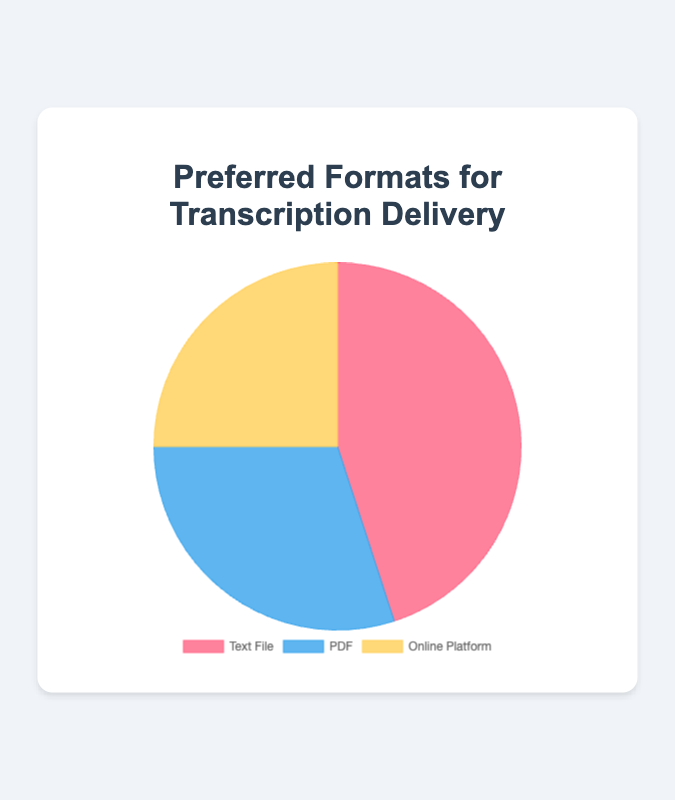How many more preferences are there for Text Files compared to Online Platforms? The number of preferences for Text Files is 45, while for Online Platforms it is 25. To find the difference, subtract the number of preferences for Online Platforms from Text Files: 45 - 25.
Answer: 20 What percentage of the total preferences is for PDF format? First, find the total number of preferences by summing up the values for Text File, PDF, and Online Platform: 45 + 30 + 25 = 100. The percentage for PDF is (30/100) * 100%.
Answer: 30% Which transcription delivery format has the least preference? By comparing the numbers, Text File has 45, PDF has 30, and Online Platform has 25 preferences. The smallest value is 25.
Answer: Online Platform What is the combined preference percentage for PDF and Online Platform? The preferences for PDF are 30, and for Online Platform are 25. Combine them by adding: 30 + 25 = 55. Now, calculate the percentage of the total: (55/100) * 100%.
Answer: 55% How does the preference for Text Files compare visually to the others in terms of its proportion in the pie chart? In the pie chart, the section for Text Files is visibly the largest, indicating it occupies the largest proportion of the chart. Text File has 45 preferences, which is the highest compared to others.
Answer: It has the largest proportion If the total number of preferences was doubled, what would be the new number of preferences for PDFs? Currently, PDF has 30 preferences. If the total was doubled, every category would also double. Hence, the new number of preferences for PDF would be 30 * 2.
Answer: 60 If five more preferences were added to the Online Platform format, what would be its new percentage of the total? The current total is 100. Adding 5 more to the Online Platform, it becomes 25 + 5 = 30. The new total preferences would be 105. The percentage for Online Platform now would be (30/105) * 100%.
Answer: 28.6% Is the number of preferences for PDFs closer to Text Files or Online Platform? The number of preferences for PDF is 30. The difference with Text Files is 45 - 30 = 15, and the difference with Online Platform is 30 - 25 = 5. Since 5 is smaller than 15, PDFs are closer to Online Platform.
Answer: Online Platform 